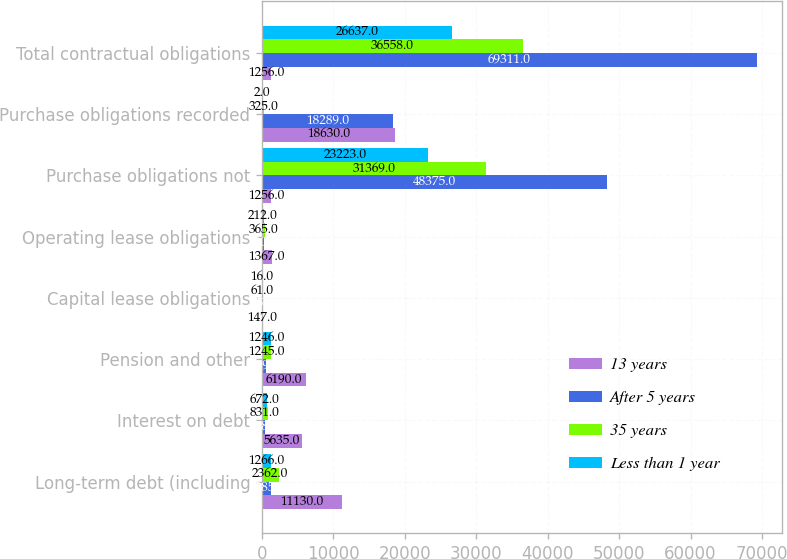<chart> <loc_0><loc_0><loc_500><loc_500><stacked_bar_chart><ecel><fcel>Long-term debt (including<fcel>Interest on debt<fcel>Pension and other<fcel>Capital lease obligations<fcel>Operating lease obligations<fcel>Purchase obligations not<fcel>Purchase obligations recorded<fcel>Total contractual obligations<nl><fcel>13 years<fcel>11130<fcel>5635<fcel>6190<fcel>147<fcel>1367<fcel>1256<fcel>18630<fcel>1256<nl><fcel>After 5 years<fcel>1285<fcel>478<fcel>609<fcel>55<fcel>220<fcel>48375<fcel>18289<fcel>69311<nl><fcel>35 years<fcel>2362<fcel>831<fcel>1245<fcel>61<fcel>365<fcel>31369<fcel>325<fcel>36558<nl><fcel>Less than 1 year<fcel>1266<fcel>672<fcel>1246<fcel>16<fcel>212<fcel>23223<fcel>2<fcel>26637<nl></chart> 